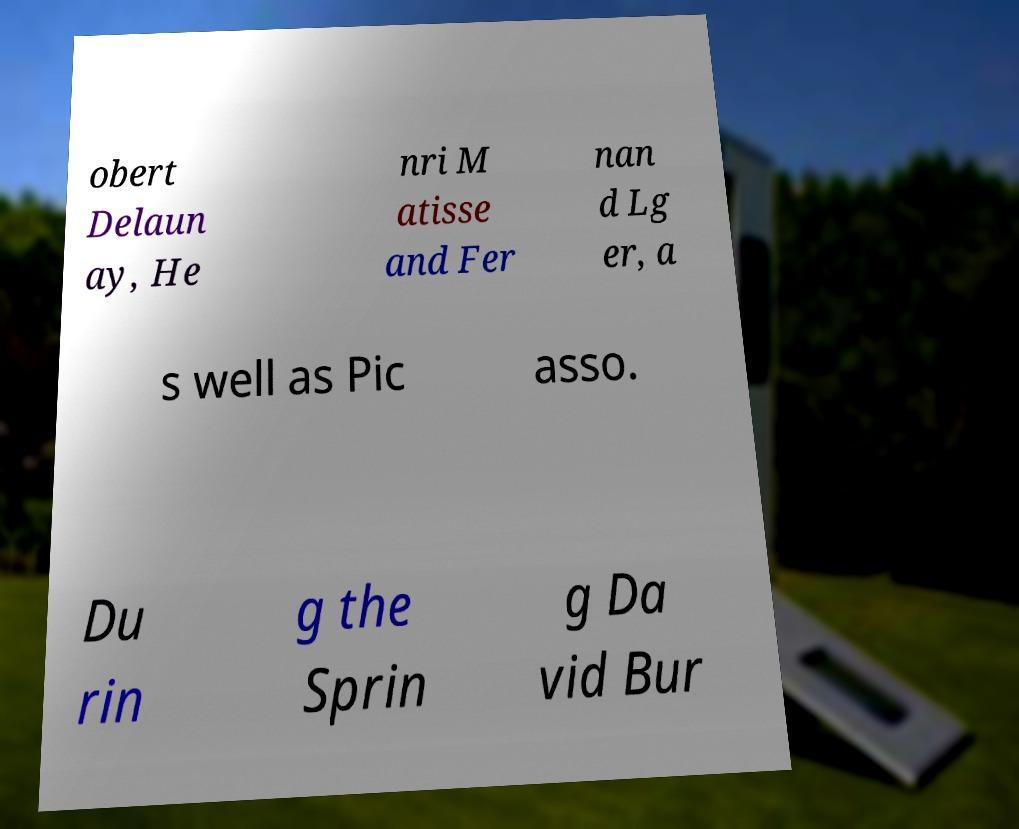Please identify and transcribe the text found in this image. obert Delaun ay, He nri M atisse and Fer nan d Lg er, a s well as Pic asso. Du rin g the Sprin g Da vid Bur 